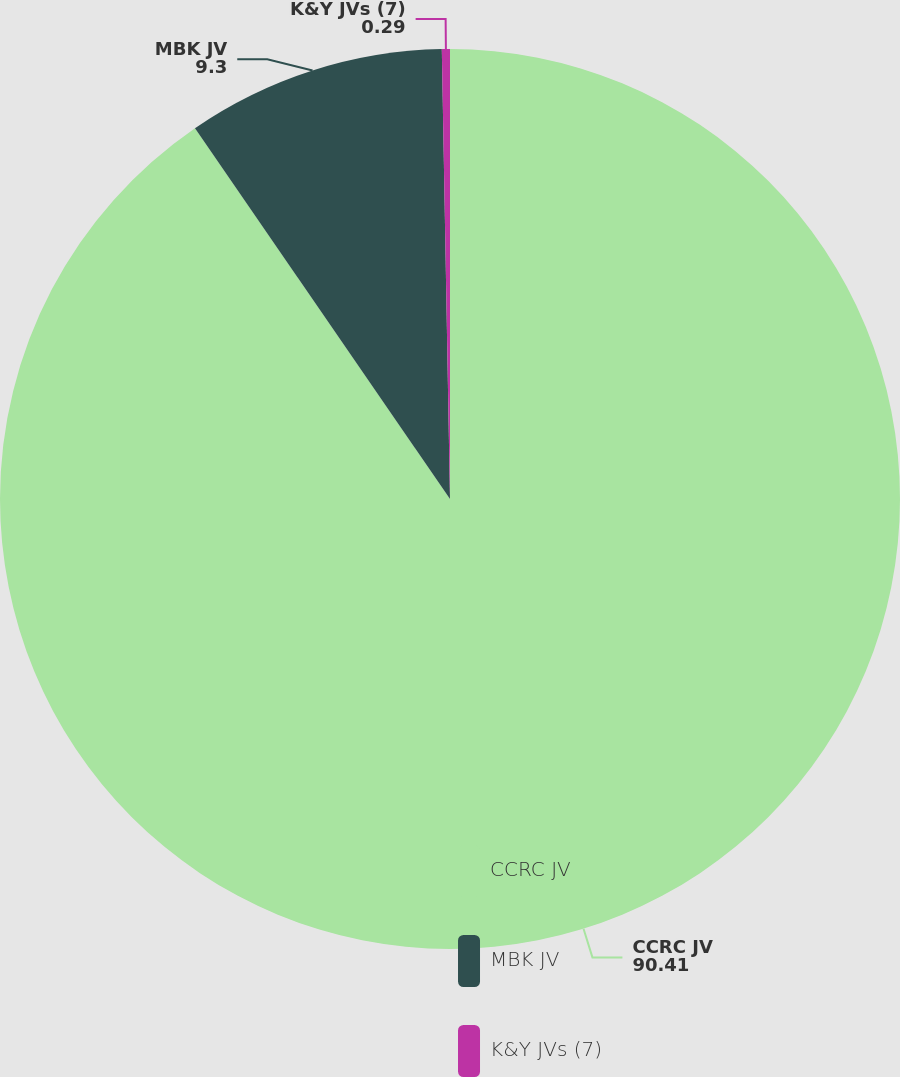Convert chart to OTSL. <chart><loc_0><loc_0><loc_500><loc_500><pie_chart><fcel>CCRC JV<fcel>MBK JV<fcel>K&Y JVs (7)<nl><fcel>90.41%<fcel>9.3%<fcel>0.29%<nl></chart> 